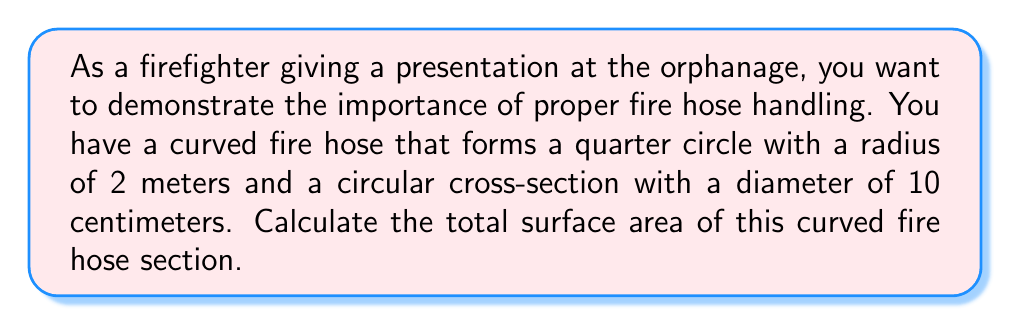Can you answer this question? To calculate the surface area of the curved fire hose, we need to consider two components:
1. The outer curved surface area
2. The area of the two circular ends

Let's approach this step-by-step:

1. Outer curved surface area:
   The hose forms a quarter circle, so we need to use the formula for the lateral surface area of a cylinder, but adjusted for a quarter circle:
   
   $$A_{outer} = \frac{1}{4} \cdot 2\pi rh$$
   
   Where $r$ is the radius of the cross-section and $h$ is the length of the centerline of the hose.
   
   The centerline length is a quarter of the circumference of a circle with radius 2 meters:
   $$h = \frac{1}{4} \cdot 2\pi R = \frac{\pi R}{2}$$
   Where $R$ is the radius of the curve (2 meters).
   
   Substituting values:
   $$A_{outer} = \frac{1}{4} \cdot 2\pi \cdot 0.05 \cdot \frac{\pi \cdot 2}{2} = \frac{\pi^2 \cdot 0.05}{2} \approx 0.2467 \text{ m}^2$$

2. Area of the two circular ends:
   Each end is a circle with diameter 10 cm (radius 5 cm):
   $$A_{ends} = 2 \cdot \pi r^2 = 2 \cdot \pi \cdot (0.05)^2 = 0.005\pi \approx 0.0157 \text{ m}^2$$

3. Total surface area:
   $$A_{total} = A_{outer} + A_{ends} = \frac{\pi^2 \cdot 0.05}{2} + 0.005\pi \approx 0.2624 \text{ m}^2$$
Answer: The total surface area of the curved fire hose section is approximately 0.2624 square meters. 